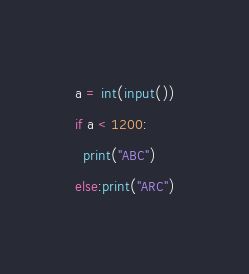Convert code to text. <code><loc_0><loc_0><loc_500><loc_500><_Python_>a = int(input())
if a < 1200:
  print("ABC")
else:print("ARC")</code> 